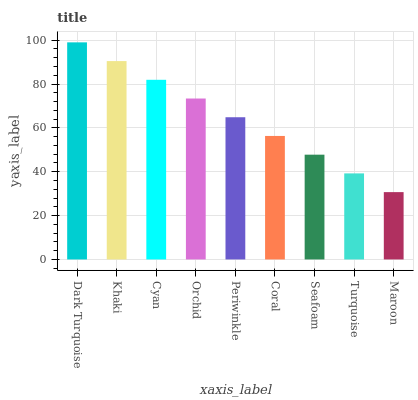Is Maroon the minimum?
Answer yes or no. Yes. Is Dark Turquoise the maximum?
Answer yes or no. Yes. Is Khaki the minimum?
Answer yes or no. No. Is Khaki the maximum?
Answer yes or no. No. Is Dark Turquoise greater than Khaki?
Answer yes or no. Yes. Is Khaki less than Dark Turquoise?
Answer yes or no. Yes. Is Khaki greater than Dark Turquoise?
Answer yes or no. No. Is Dark Turquoise less than Khaki?
Answer yes or no. No. Is Periwinkle the high median?
Answer yes or no. Yes. Is Periwinkle the low median?
Answer yes or no. Yes. Is Orchid the high median?
Answer yes or no. No. Is Khaki the low median?
Answer yes or no. No. 